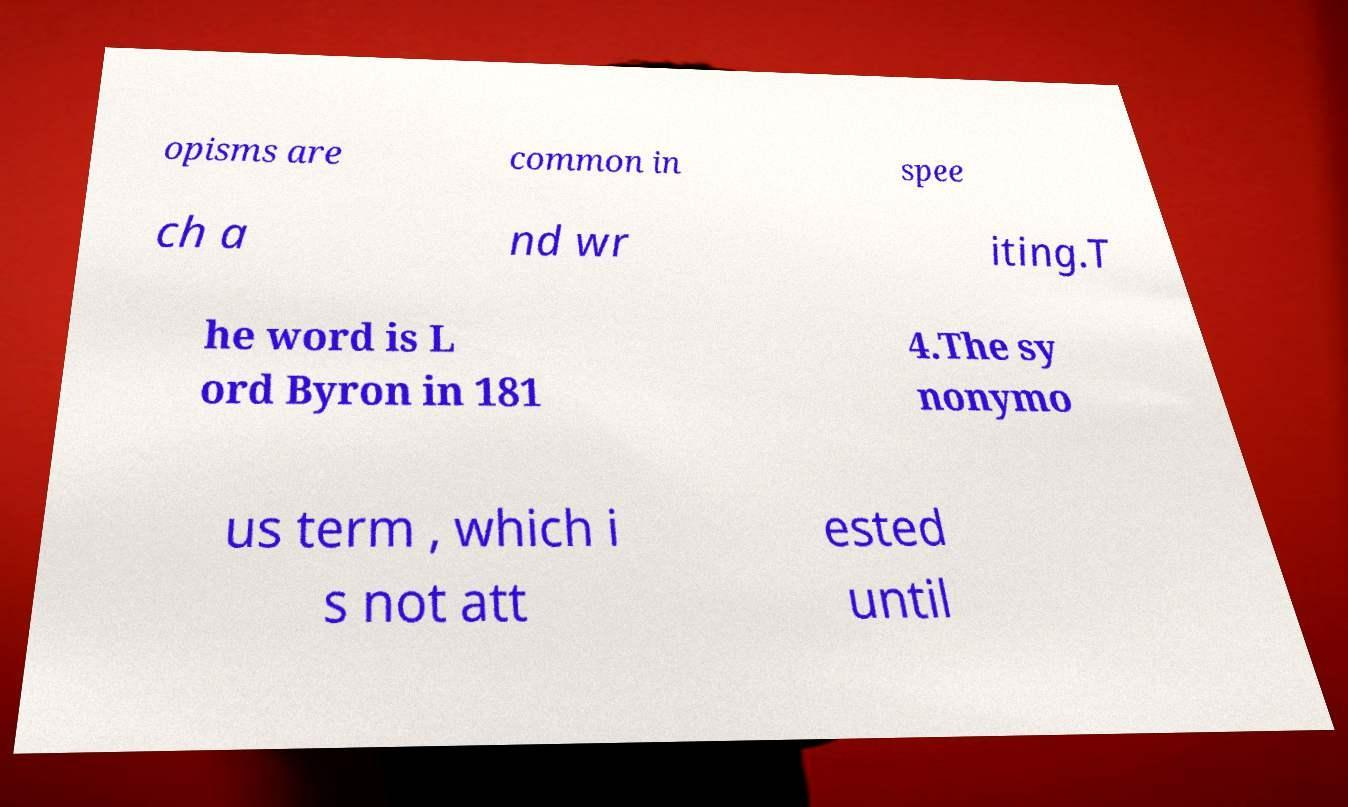Could you extract and type out the text from this image? opisms are common in spee ch a nd wr iting.T he word is L ord Byron in 181 4.The sy nonymo us term , which i s not att ested until 